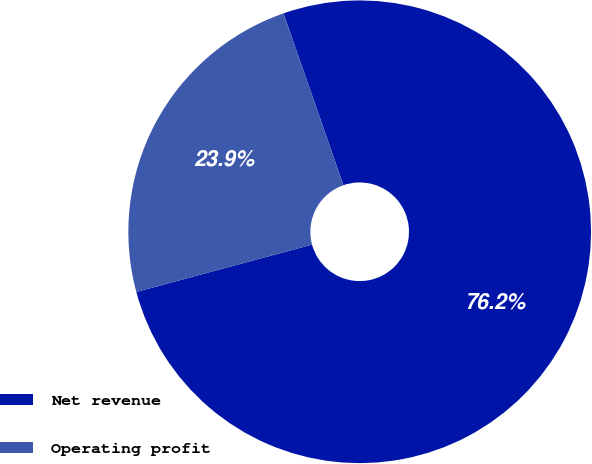<chart> <loc_0><loc_0><loc_500><loc_500><pie_chart><fcel>Net revenue<fcel>Operating profit<nl><fcel>76.15%<fcel>23.85%<nl></chart> 